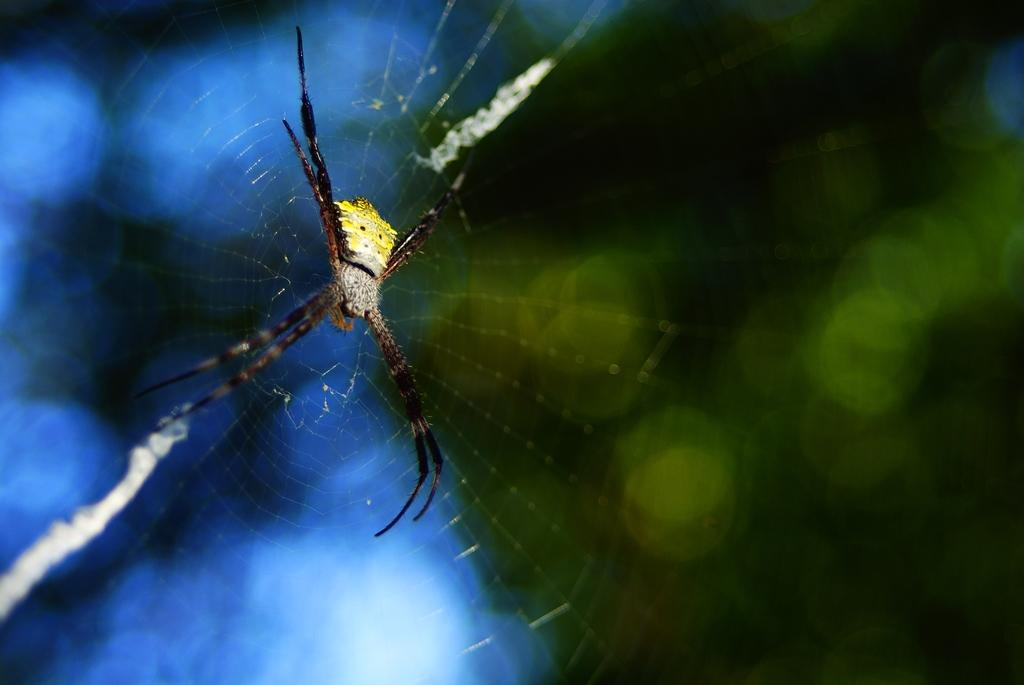What is present in the image? There is a spider in the image. Where is the spider located? The spider is in a web. Can you see a squirrel moving around in the image? There is no squirrel present in the image. What type of bean is visible in the image? There is no bean present in the image. 